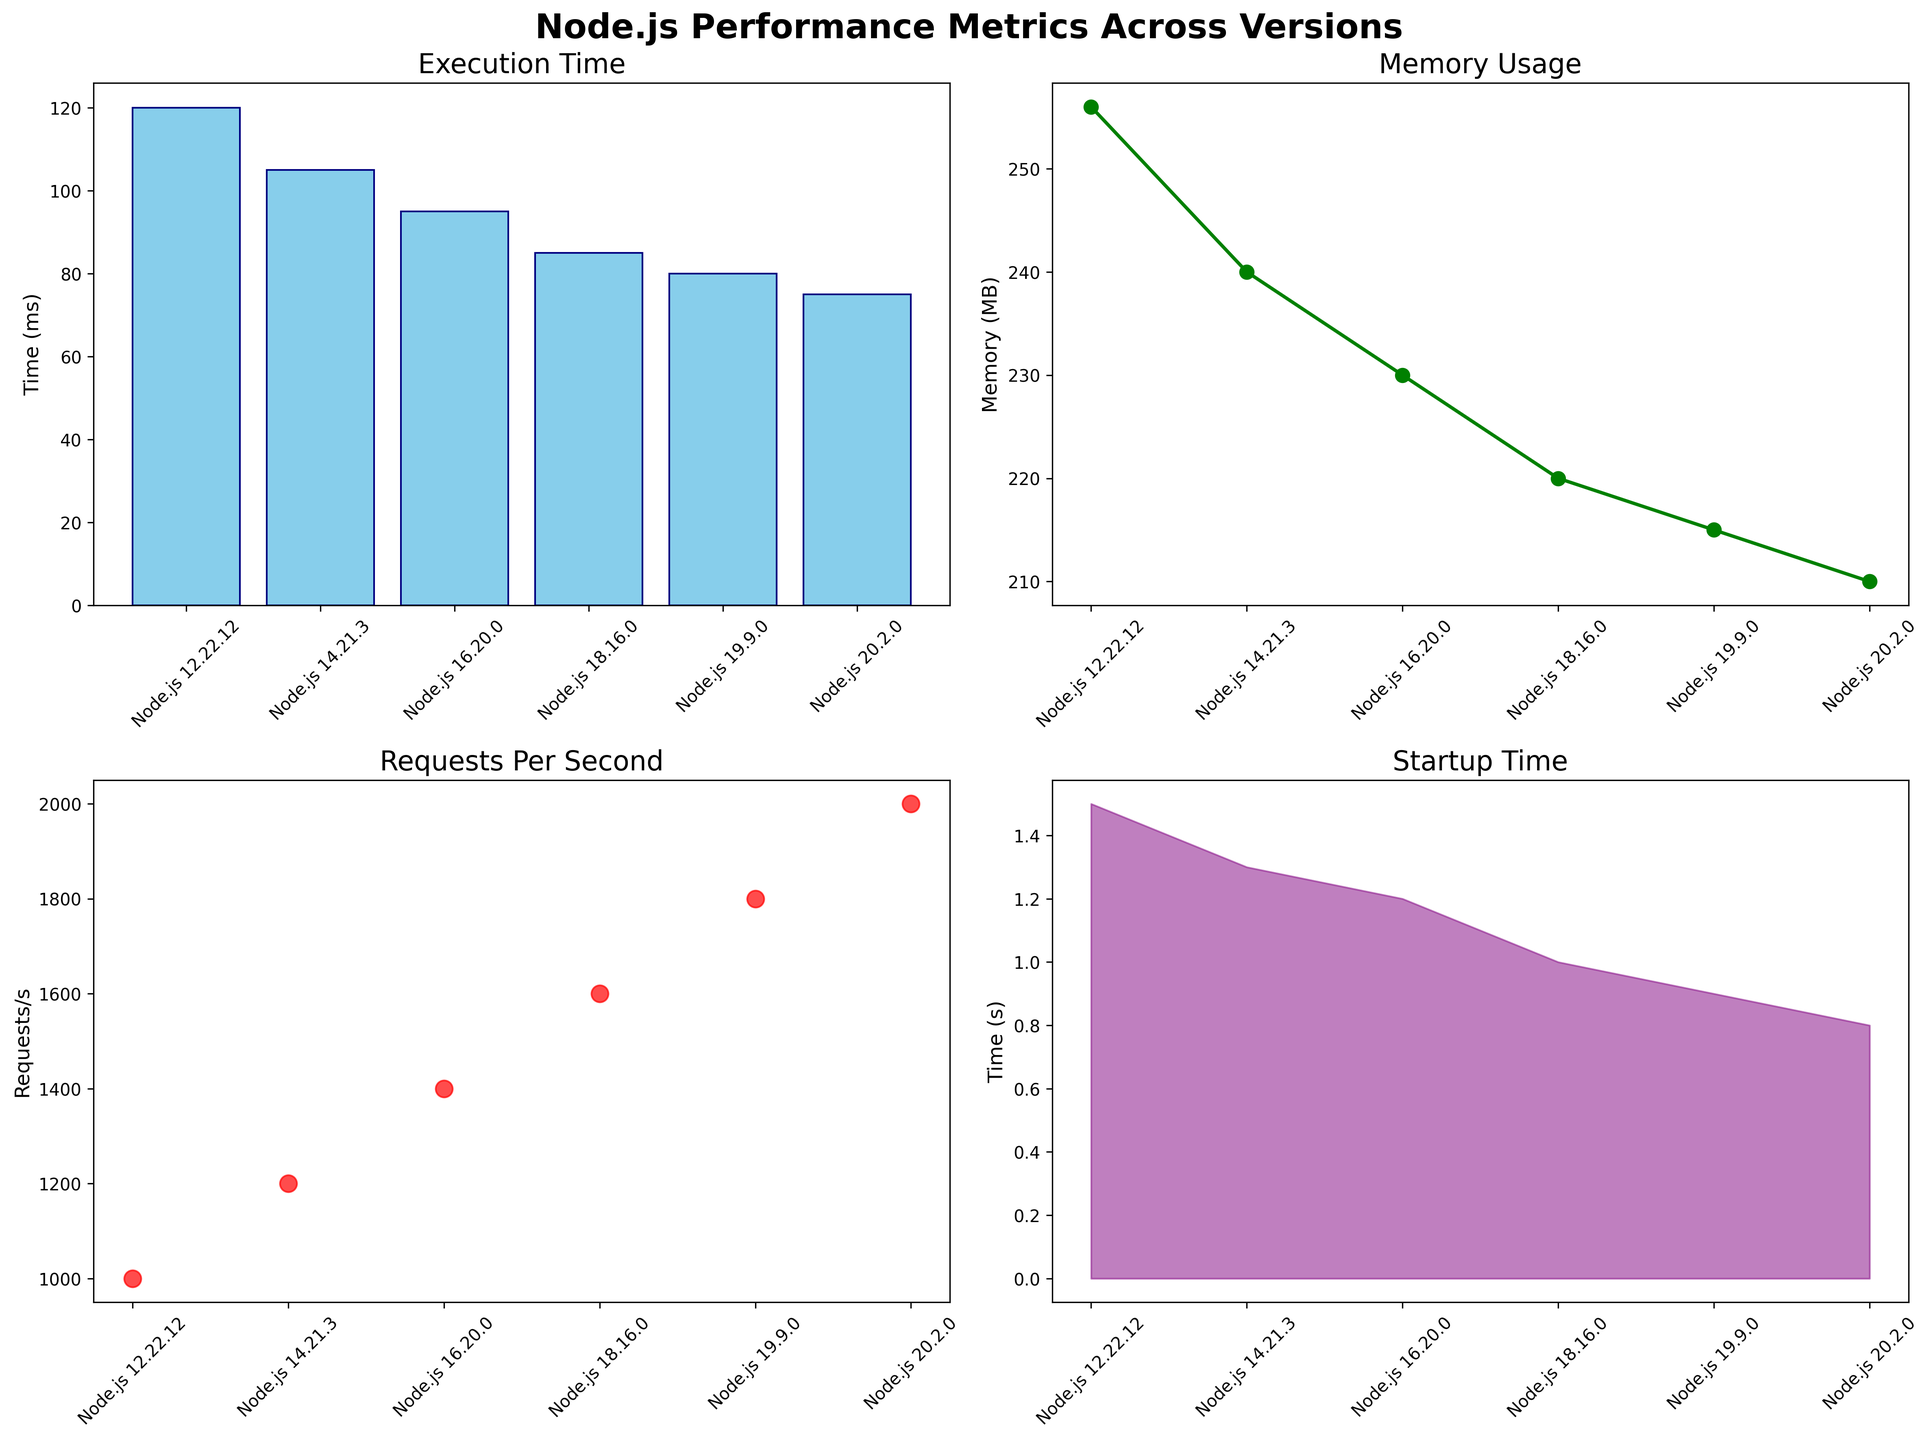Which Node.js version has the highest memory usage? To determine the highest memory usage, we can simply look at the 'Memory Usage' line plot and identify the peak value. The version corresponding to this peak value is Node.js 12.22.12 with 256 MB.
Answer: Node.js 12.22.12 What is the difference in execution time between Node.js 16.20.0 and Node.js 20.2.0? In the 'Execution Time' bar plot, the execution time for Node.js 16.20.0 is 95 ms, and for Node.js 20.2.0, it is 75 ms. The difference is 95 - 75 = 20 ms.
Answer: 20 ms Which version shows the lowest startup time? The lowest startup time can be identified by looking at the minimum point in the 'Startup Time' area plot. The version with the lowest startup time is Node.js 20.2.0 with 0.8 seconds.
Answer: Node.js 20.2.0 Compare the number of requests per second for Node.js 14.21.3 and Node.js 18.16.0. Which version is better? By observing the 'Requests Per Second' scatter plot, Node.js 14.21.3 supports 1200 requests per second, whereas Node.js 18.16.0 supports 1600 requests per second. Node.js 18.16.0 performs better with higher requests per second.
Answer: Node.js 18.16.0 What is the trend in execution time as Node.js versions are updated from 12.22.12 to 20.2.0? The 'Execution Time' bar plot shows a decreasing trend in execution time as Node.js versions are updated, reflecting performance improvement. As versions advance from 12.22.12 to 20.2.0, execution time reduces from 120 ms to 75 ms.
Answer: Decreasing trend How does the memory usage change between Node.js 14.21.3 and Node.js 19.9.0? From the 'Memory Usage' line plot, Node.js 14.21.3 has a memory usage of 240 MB, and Node.js 19.9.0 has 215 MB. The memory usage decreases by 240 - 215 = 25 MB.
Answer: Decreases by 25 MB Which version has the highest requests per second, and what is its value? In the 'Requests Per Second' scatter plot, the version with the highest number of requests per second is Node.js 20.2.0, with a value of 2000 requests/s.
Answer: Node.js 20.2.0, 2000 requests/s Calculate the average execution time across all Node.js versions presented. Summing up the execution times: 120 + 105 + 95 + 85 + 80 + 75 = 560 ms. Dividing by the number of versions (6), the average execution time is 560 / 6 ≈ 93.33 ms.
Answer: 93.33 ms Between Node.js 12.22.12 and Node.js 20.2.0, which version has a better performance in terms of startup time and by how much? From the 'Startup Time' area plot, Node.js 12.22.12 has a startup time of 1.5 seconds, and Node.js 20.2.0 has 0.8 seconds. Node.js 20.2.0 performs better by 1.5 - 0.8 = 0.7 seconds.
Answer: Node.js 20.2.0, 0.7 seconds 